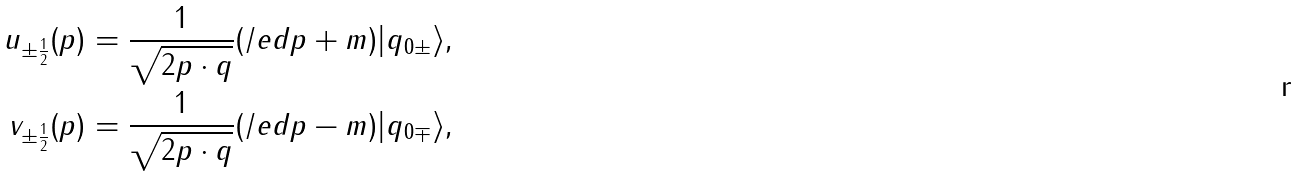Convert formula to latex. <formula><loc_0><loc_0><loc_500><loc_500>u _ { \pm \frac { 1 } { 2 } } ( p ) & = \frac { 1 } { \sqrt { 2 p \cdot q } } ( \slash e d { p } + m ) | q _ { 0 \pm } \rangle , \\ v _ { \pm \frac { 1 } { 2 } } ( p ) & = \frac { 1 } { \sqrt { 2 p \cdot q } } ( \slash e d { p } - m ) | q _ { 0 \mp } \rangle ,</formula> 